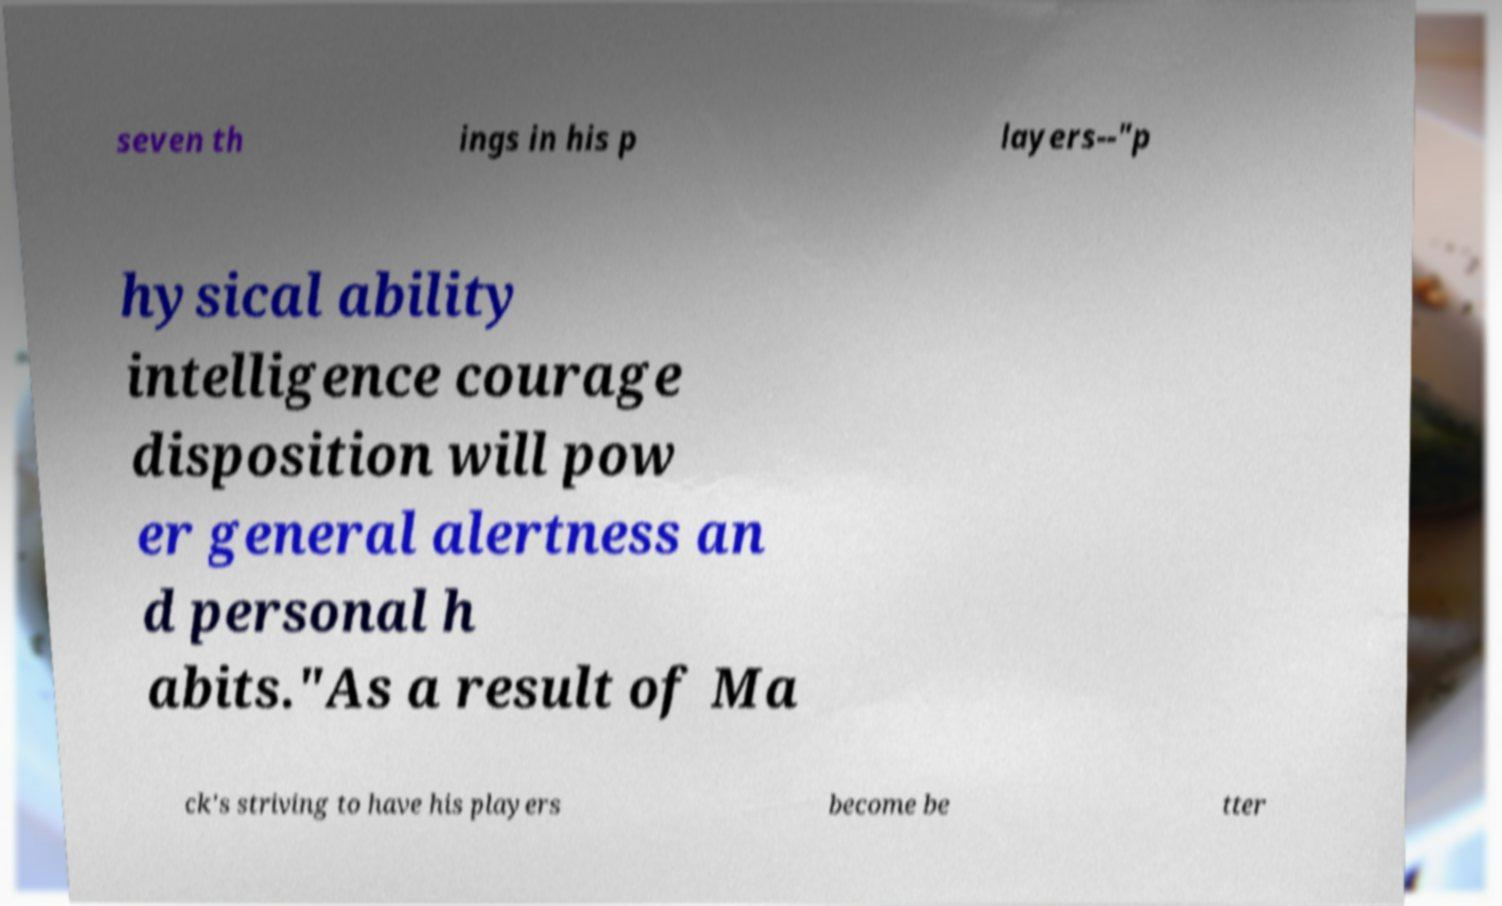Can you accurately transcribe the text from the provided image for me? seven th ings in his p layers--"p hysical ability intelligence courage disposition will pow er general alertness an d personal h abits."As a result of Ma ck's striving to have his players become be tter 